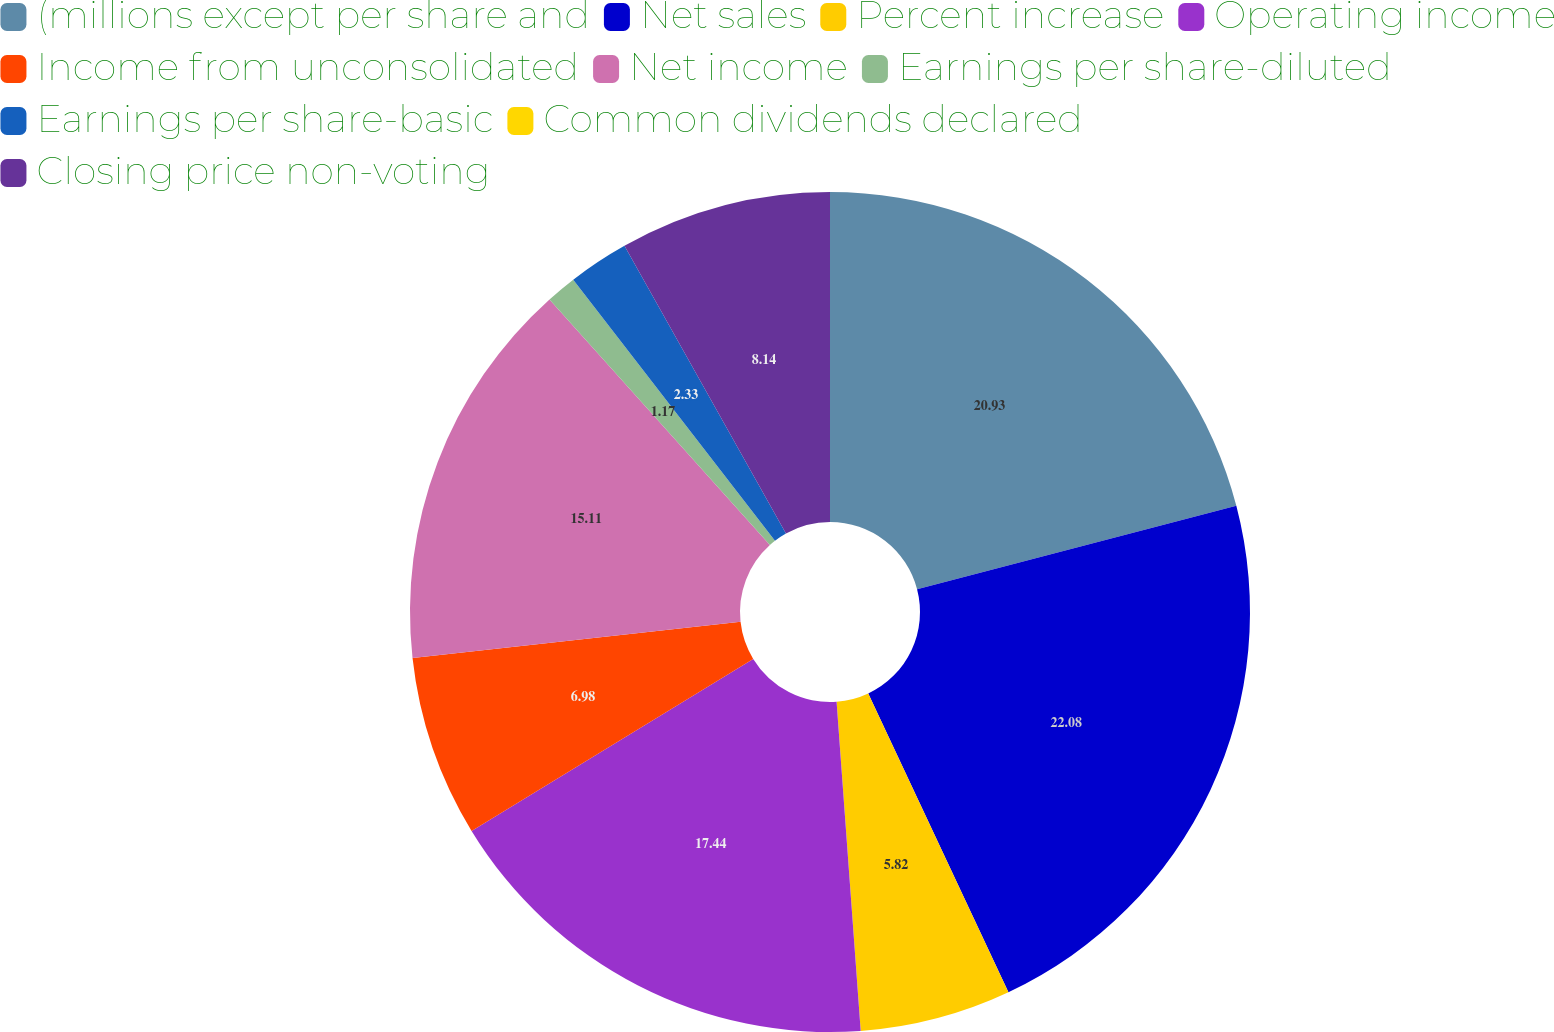Convert chart to OTSL. <chart><loc_0><loc_0><loc_500><loc_500><pie_chart><fcel>(millions except per share and<fcel>Net sales<fcel>Percent increase<fcel>Operating income<fcel>Income from unconsolidated<fcel>Net income<fcel>Earnings per share-diluted<fcel>Earnings per share-basic<fcel>Common dividends declared<fcel>Closing price non-voting<nl><fcel>20.93%<fcel>22.09%<fcel>5.82%<fcel>17.44%<fcel>6.98%<fcel>15.11%<fcel>1.17%<fcel>2.33%<fcel>0.0%<fcel>8.14%<nl></chart> 